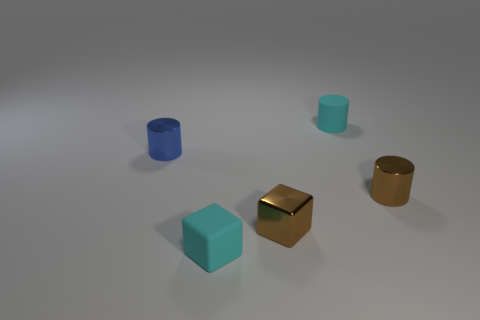Subtract all tiny shiny cylinders. How many cylinders are left? 1 Add 2 brown matte cylinders. How many objects exist? 7 Subtract all small cyan matte cylinders. Subtract all tiny brown blocks. How many objects are left? 3 Add 4 brown cylinders. How many brown cylinders are left? 5 Add 3 brown cylinders. How many brown cylinders exist? 4 Subtract 1 brown cubes. How many objects are left? 4 Subtract all cylinders. How many objects are left? 2 